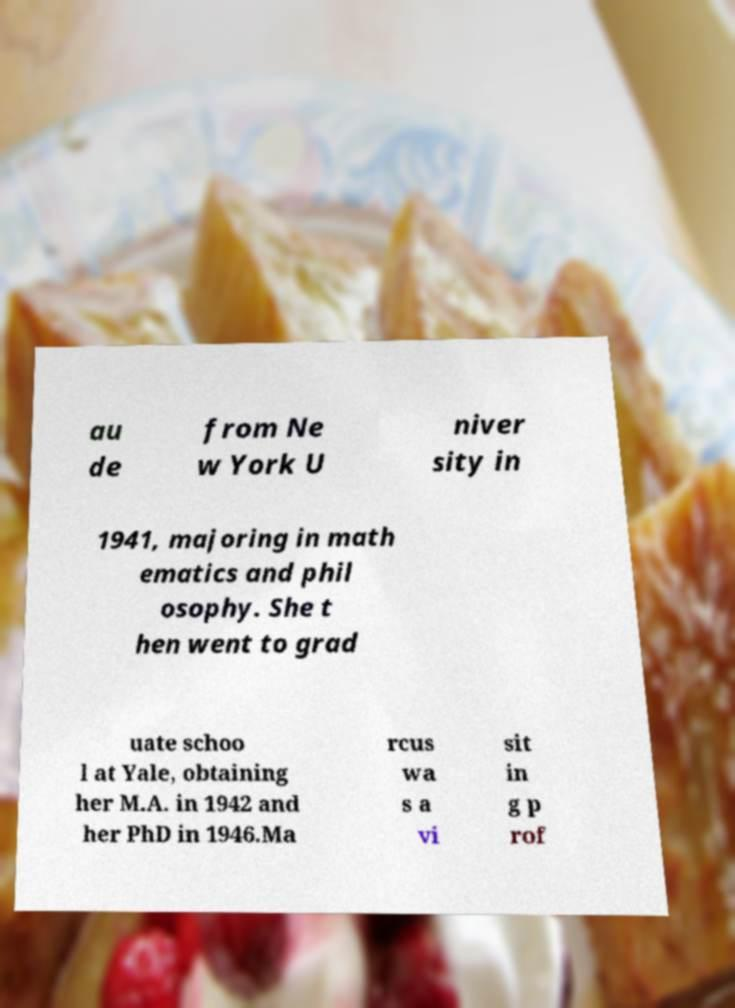Can you accurately transcribe the text from the provided image for me? au de from Ne w York U niver sity in 1941, majoring in math ematics and phil osophy. She t hen went to grad uate schoo l at Yale, obtaining her M.A. in 1942 and her PhD in 1946.Ma rcus wa s a vi sit in g p rof 